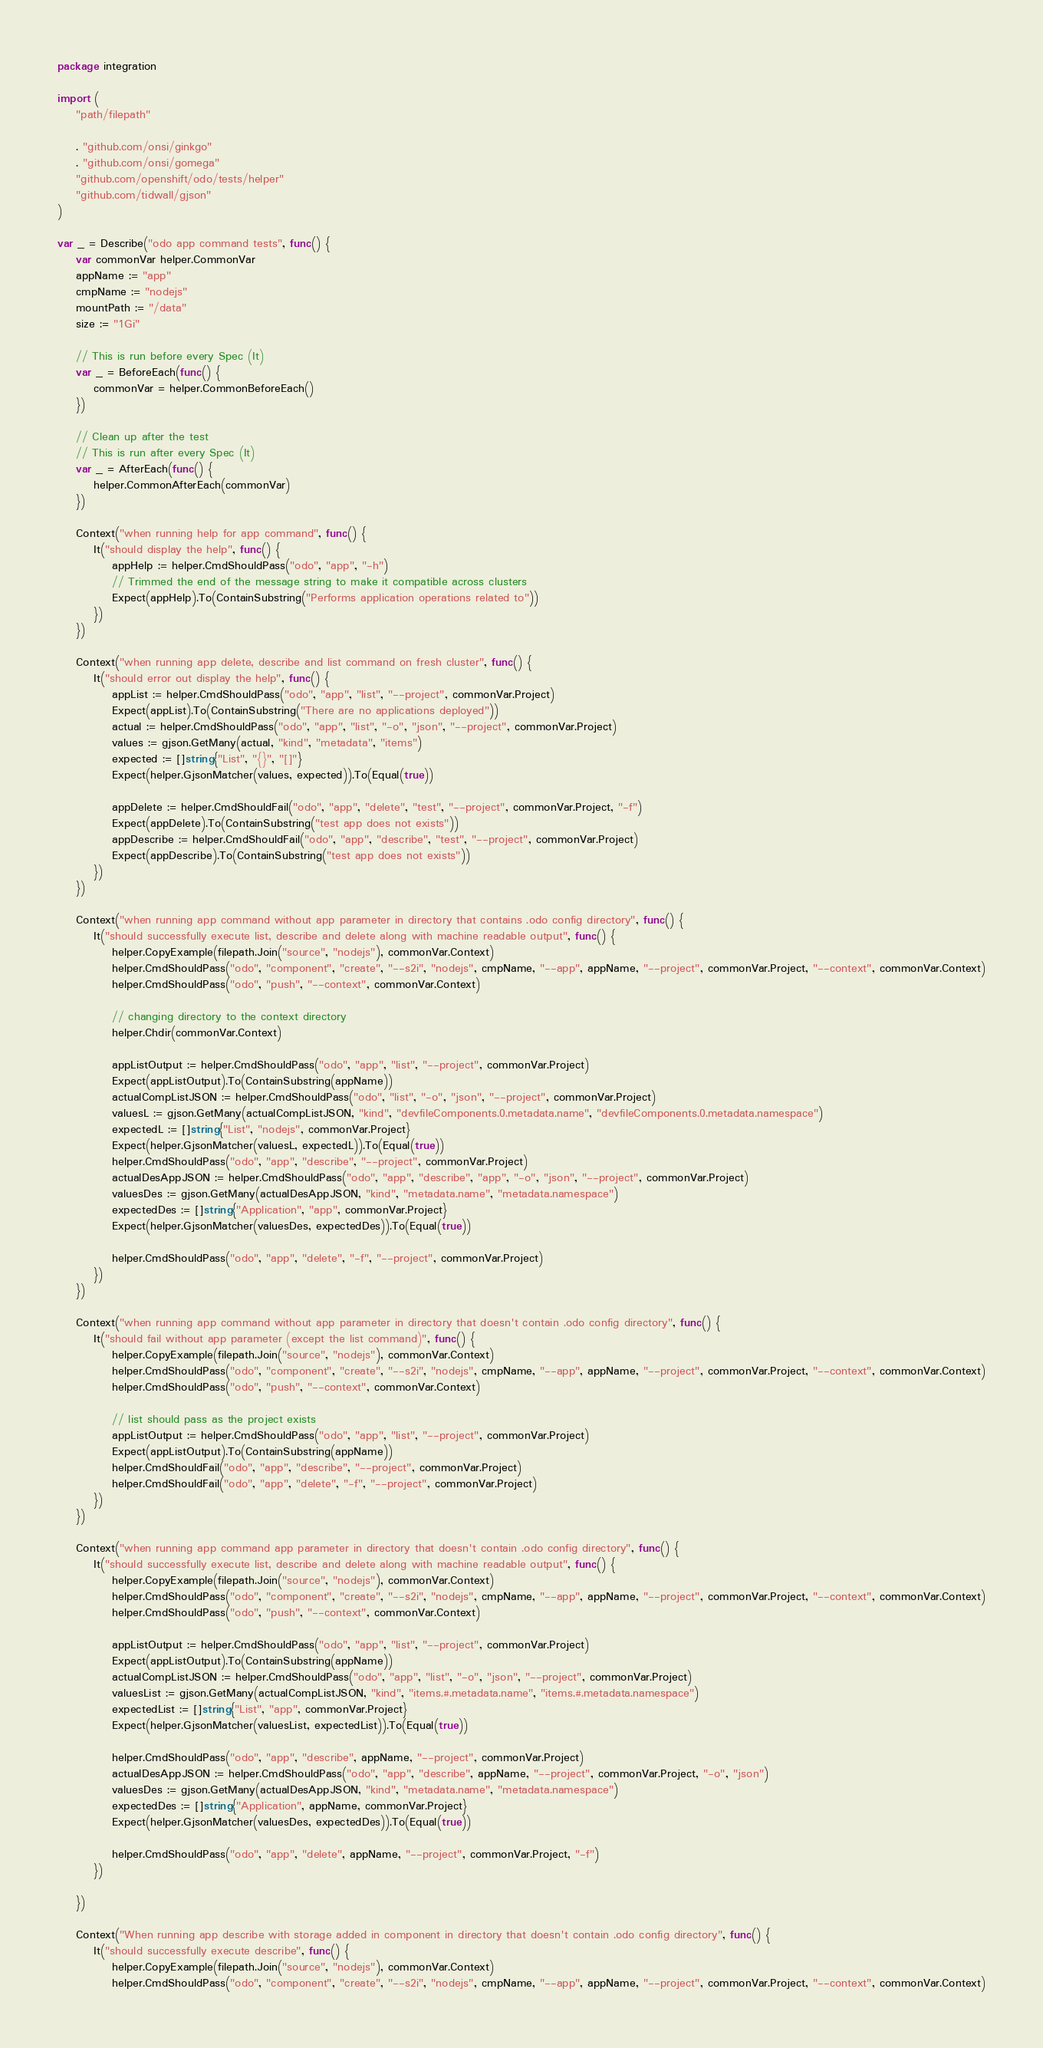<code> <loc_0><loc_0><loc_500><loc_500><_Go_>package integration

import (
	"path/filepath"

	. "github.com/onsi/ginkgo"
	. "github.com/onsi/gomega"
	"github.com/openshift/odo/tests/helper"
	"github.com/tidwall/gjson"
)

var _ = Describe("odo app command tests", func() {
	var commonVar helper.CommonVar
	appName := "app"
	cmpName := "nodejs"
	mountPath := "/data"
	size := "1Gi"

	// This is run before every Spec (It)
	var _ = BeforeEach(func() {
		commonVar = helper.CommonBeforeEach()
	})

	// Clean up after the test
	// This is run after every Spec (It)
	var _ = AfterEach(func() {
		helper.CommonAfterEach(commonVar)
	})

	Context("when running help for app command", func() {
		It("should display the help", func() {
			appHelp := helper.CmdShouldPass("odo", "app", "-h")
			// Trimmed the end of the message string to make it compatible across clusters
			Expect(appHelp).To(ContainSubstring("Performs application operations related to"))
		})
	})

	Context("when running app delete, describe and list command on fresh cluster", func() {
		It("should error out display the help", func() {
			appList := helper.CmdShouldPass("odo", "app", "list", "--project", commonVar.Project)
			Expect(appList).To(ContainSubstring("There are no applications deployed"))
			actual := helper.CmdShouldPass("odo", "app", "list", "-o", "json", "--project", commonVar.Project)
			values := gjson.GetMany(actual, "kind", "metadata", "items")
			expected := []string{"List", "{}", "[]"}
			Expect(helper.GjsonMatcher(values, expected)).To(Equal(true))

			appDelete := helper.CmdShouldFail("odo", "app", "delete", "test", "--project", commonVar.Project, "-f")
			Expect(appDelete).To(ContainSubstring("test app does not exists"))
			appDescribe := helper.CmdShouldFail("odo", "app", "describe", "test", "--project", commonVar.Project)
			Expect(appDescribe).To(ContainSubstring("test app does not exists"))
		})
	})

	Context("when running app command without app parameter in directory that contains .odo config directory", func() {
		It("should successfully execute list, describe and delete along with machine readable output", func() {
			helper.CopyExample(filepath.Join("source", "nodejs"), commonVar.Context)
			helper.CmdShouldPass("odo", "component", "create", "--s2i", "nodejs", cmpName, "--app", appName, "--project", commonVar.Project, "--context", commonVar.Context)
			helper.CmdShouldPass("odo", "push", "--context", commonVar.Context)

			// changing directory to the context directory
			helper.Chdir(commonVar.Context)

			appListOutput := helper.CmdShouldPass("odo", "app", "list", "--project", commonVar.Project)
			Expect(appListOutput).To(ContainSubstring(appName))
			actualCompListJSON := helper.CmdShouldPass("odo", "list", "-o", "json", "--project", commonVar.Project)
			valuesL := gjson.GetMany(actualCompListJSON, "kind", "devfileComponents.0.metadata.name", "devfileComponents.0.metadata.namespace")
			expectedL := []string{"List", "nodejs", commonVar.Project}
			Expect(helper.GjsonMatcher(valuesL, expectedL)).To(Equal(true))
			helper.CmdShouldPass("odo", "app", "describe", "--project", commonVar.Project)
			actualDesAppJSON := helper.CmdShouldPass("odo", "app", "describe", "app", "-o", "json", "--project", commonVar.Project)
			valuesDes := gjson.GetMany(actualDesAppJSON, "kind", "metadata.name", "metadata.namespace")
			expectedDes := []string{"Application", "app", commonVar.Project}
			Expect(helper.GjsonMatcher(valuesDes, expectedDes)).To(Equal(true))

			helper.CmdShouldPass("odo", "app", "delete", "-f", "--project", commonVar.Project)
		})
	})

	Context("when running app command without app parameter in directory that doesn't contain .odo config directory", func() {
		It("should fail without app parameter (except the list command)", func() {
			helper.CopyExample(filepath.Join("source", "nodejs"), commonVar.Context)
			helper.CmdShouldPass("odo", "component", "create", "--s2i", "nodejs", cmpName, "--app", appName, "--project", commonVar.Project, "--context", commonVar.Context)
			helper.CmdShouldPass("odo", "push", "--context", commonVar.Context)

			// list should pass as the project exists
			appListOutput := helper.CmdShouldPass("odo", "app", "list", "--project", commonVar.Project)
			Expect(appListOutput).To(ContainSubstring(appName))
			helper.CmdShouldFail("odo", "app", "describe", "--project", commonVar.Project)
			helper.CmdShouldFail("odo", "app", "delete", "-f", "--project", commonVar.Project)
		})
	})

	Context("when running app command app parameter in directory that doesn't contain .odo config directory", func() {
		It("should successfully execute list, describe and delete along with machine readable output", func() {
			helper.CopyExample(filepath.Join("source", "nodejs"), commonVar.Context)
			helper.CmdShouldPass("odo", "component", "create", "--s2i", "nodejs", cmpName, "--app", appName, "--project", commonVar.Project, "--context", commonVar.Context)
			helper.CmdShouldPass("odo", "push", "--context", commonVar.Context)

			appListOutput := helper.CmdShouldPass("odo", "app", "list", "--project", commonVar.Project)
			Expect(appListOutput).To(ContainSubstring(appName))
			actualCompListJSON := helper.CmdShouldPass("odo", "app", "list", "-o", "json", "--project", commonVar.Project)
			valuesList := gjson.GetMany(actualCompListJSON, "kind", "items.#.metadata.name", "items.#.metadata.namespace")
			expectedList := []string{"List", "app", commonVar.Project}
			Expect(helper.GjsonMatcher(valuesList, expectedList)).To(Equal(true))

			helper.CmdShouldPass("odo", "app", "describe", appName, "--project", commonVar.Project)
			actualDesAppJSON := helper.CmdShouldPass("odo", "app", "describe", appName, "--project", commonVar.Project, "-o", "json")
			valuesDes := gjson.GetMany(actualDesAppJSON, "kind", "metadata.name", "metadata.namespace")
			expectedDes := []string{"Application", appName, commonVar.Project}
			Expect(helper.GjsonMatcher(valuesDes, expectedDes)).To(Equal(true))

			helper.CmdShouldPass("odo", "app", "delete", appName, "--project", commonVar.Project, "-f")
		})

	})

	Context("When running app describe with storage added in component in directory that doesn't contain .odo config directory", func() {
		It("should successfully execute describe", func() {
			helper.CopyExample(filepath.Join("source", "nodejs"), commonVar.Context)
			helper.CmdShouldPass("odo", "component", "create", "--s2i", "nodejs", cmpName, "--app", appName, "--project", commonVar.Project, "--context", commonVar.Context)</code> 